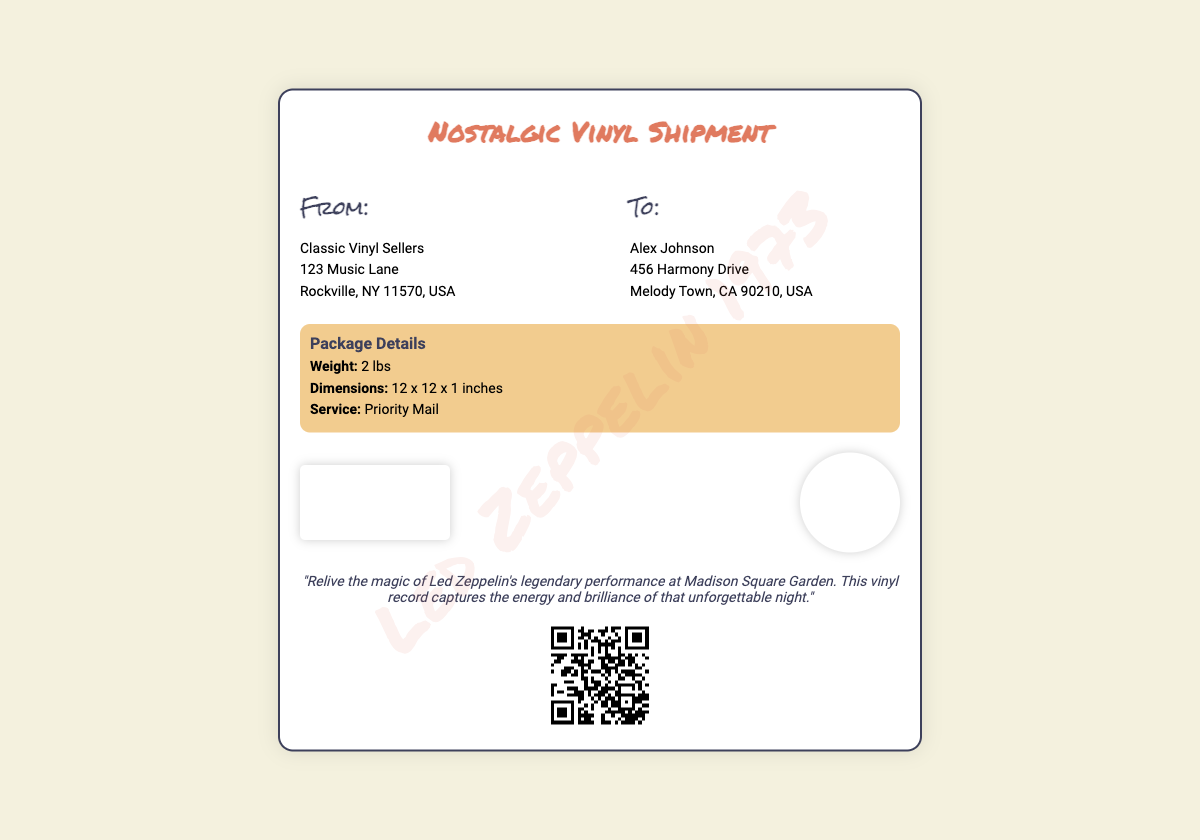What is the product being shipped? The product in the shipping label is identified as a nostalgic vinyl record of Led Zeppelin's concert.
Answer: Led Zeppelin vinyl record Who is the sender? The sender information includes the name and address listed at the top of the document.
Answer: Classic Vinyl Sellers What is the weight of the package? The weight of the package is mentioned in the package details section.
Answer: 2 lbs What type of mail service is used? The service type is specified within the package details section.
Answer: Priority Mail Who is the recipient? The recipient's name and address can be found on the shipping label.
Answer: Alex Johnson What concert is featured on the vinyl? The concert mentioned is specified in the nostalgia message on the label.
Answer: Madison Square Garden What year did the concert take place? The year of the concert is indicated in the watermark at the bottom of the label.
Answer: 1973 How many different fonts are used in the document? The document includes three different font styles as indicated in the stylesheet.
Answer: Three What is the URL for tracking the shipment? The URL for tracking the shipment is included in the QR code section of the label.
Answer: https://example.com/track?shipment_id=123456 